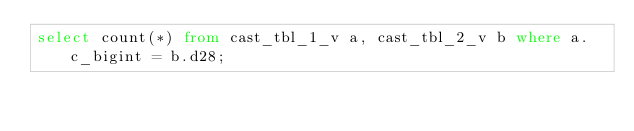Convert code to text. <code><loc_0><loc_0><loc_500><loc_500><_SQL_>select count(*) from cast_tbl_1_v a, cast_tbl_2_v b where a.c_bigint = b.d28;
</code> 